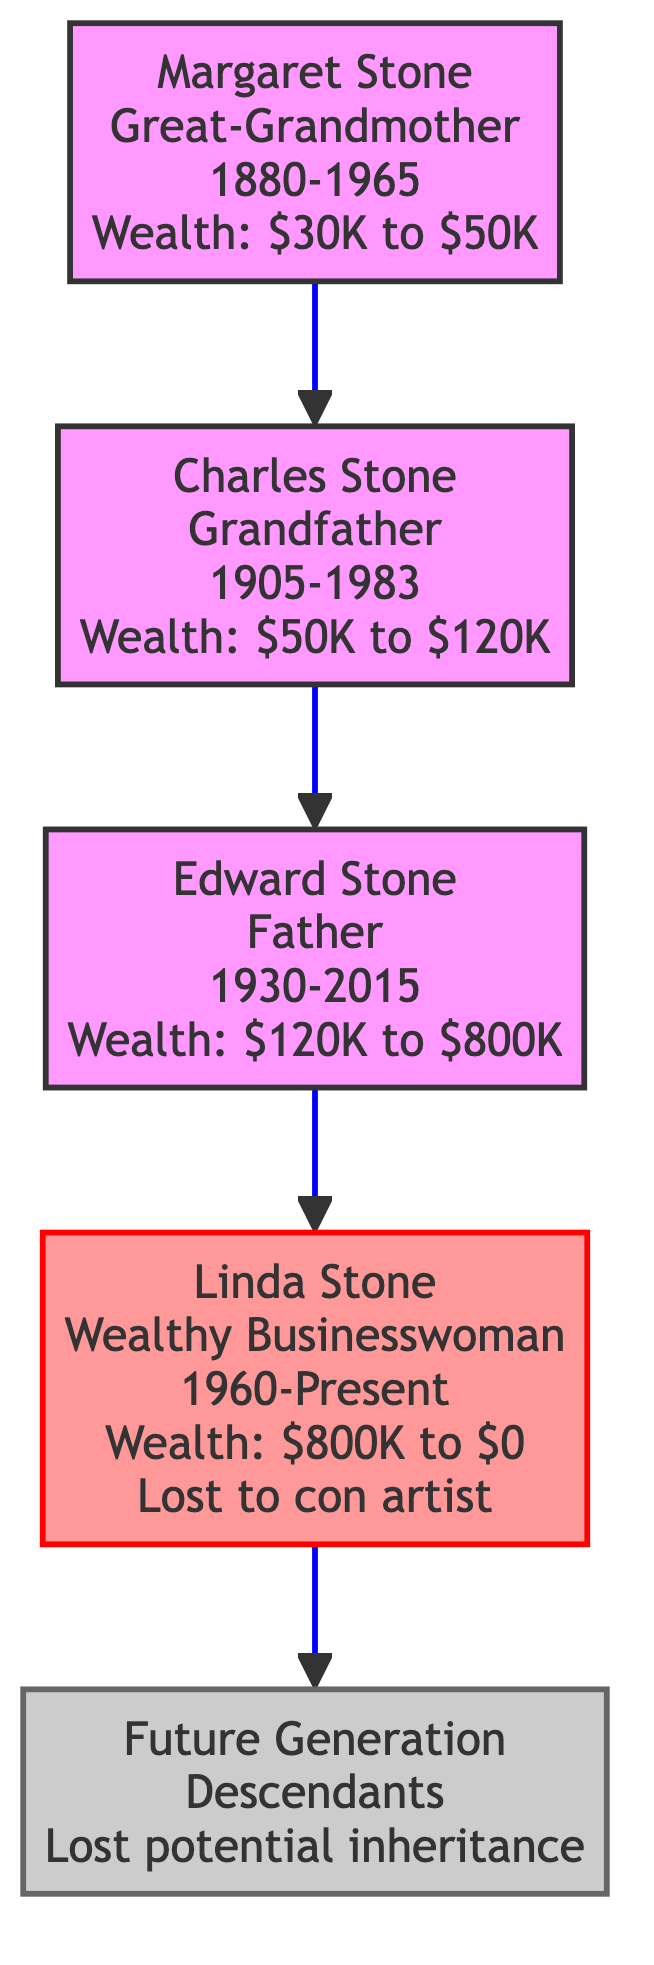What is the wealth range of Charles Stone? According to the diagram, Charles Stone's wealth started at $50,000 and ended at $120,000, so his wealth range is from $50k to $120k.
Answer: $50K to $120K What was the primary asset moved by Edward Stone? Looking at the diagram, Edward Stone moved multiple assets, but the primary one listed is "Multiple properties in New York," which indicates significant real estate value.
Answer: Multiple properties in New York How much cash did Margaret Stone leave? The diagram states that Margaret Stone had $20,000 in cash at the time of her asset movement.
Answer: $20,000 Who lost the most wealth in the family? Among all family members, Linda Stone has the wealth that changed from $800,000 to $0 due to the loss from a con artist scheme, making her the one who lost the most wealth.
Answer: Linda Stone How many generations are represented in the diagram? The diagram shows four generations: Great-Grandmother, Grandfather, Father, and the Wealthy Businesswoman, along with a placeholder for Future Generations, totaling five entities but four distinct generational layers.
Answer: Four What was the total wealth of Edward Stone when he passed away? According to the diagram, Edward Stone's wealth at the end of his life was $800,000, which is clearly stated there.
Answer: $800,000 Which family member's wealth ended at zero? The diagram indicates that Linda Stone's wealth ended at zero due to losses from a con artist, explicitly mentioned in her section.
Answer: Linda Stone What was the role of Margaret Stone in the family tree? Margaret Stone is labeled as the Great-Grandmother, which identifies her as the matriarch and the topmost member in this family legacy representation.
Answer: Great-Grandmother What asset type did Linda Stone lose along with her cash? The diagram specifies that Linda Stone lost "Expensive Jewelry Collection," apart from the substantial cash amount that she lost, indicating both cash and luxury items were lost.
Answer: Expensive Jewelry Collection 